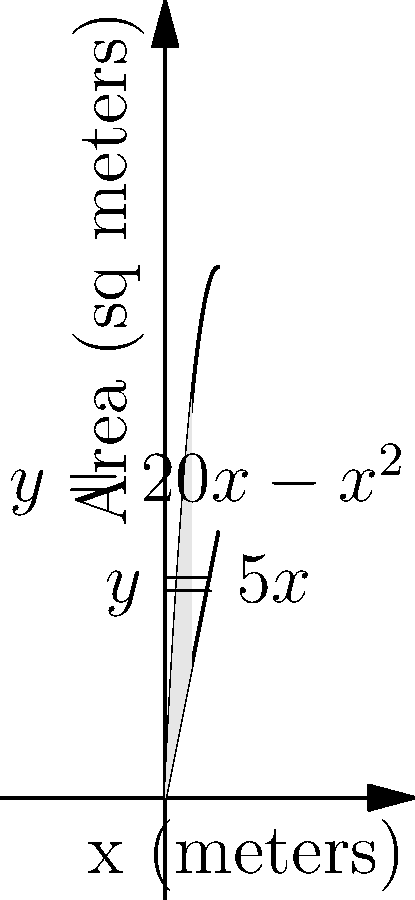As an HR professional studying organizational innovation, you're tasked with optimizing office space layout. The graph shows two functions: $y = 20x - x^2$ (upper curve) and $y = 5x$ (lower line), where $x$ represents the width of the office space in meters, and $y$ represents the area in square meters. What is the maximum area between these two functions, which represents the optimal collaborative space? To find the maximum area between the two functions, we need to:

1) Find the points of intersection:
   $20x - x^2 = 5x$
   $15x - x^2 = 0$
   $x(15 - x) = 0$
   $x = 0$ or $x = 15$

2) Set up the integral to calculate the area:
   Area = $\int_0^{15} [(20x - x^2) - 5x] dx$

3) Solve the integral:
   $\int_0^{15} (15x - x^2) dx$
   $= [15\frac{x^2}{2} - \frac{x^3}{3}]_0^{15}$
   $= (15\frac{225}{2} - \frac{3375}{3}) - 0$
   $= 1687.5 - 1125 = 562.5$

Therefore, the maximum area between the two functions is 562.5 square meters.
Answer: 562.5 square meters 